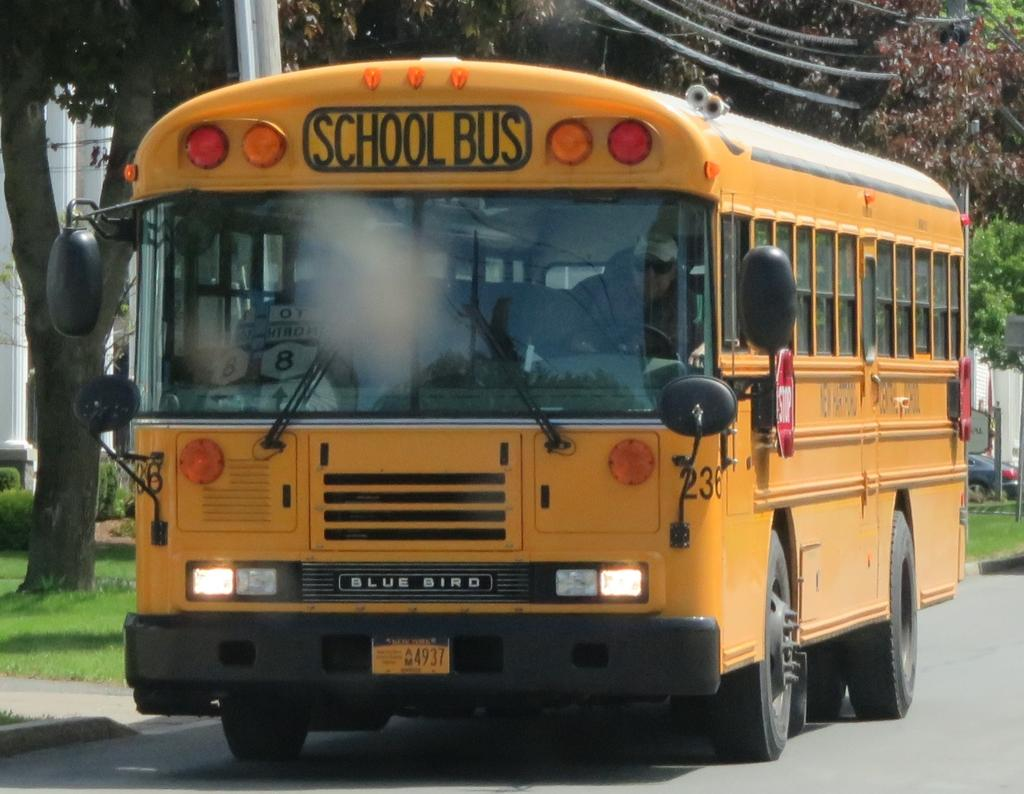What type of vehicle is on the road in the image? There is a school bus on the road in the image. What can be seen in the background of the image? Trees and electrical poles with wires are visible in the background. What type of structure is in the image? There is a building in the image. What type of vegetation is visible in the image? Grass is visible in the image. Can you tell me how many volleyballs are on the roof of the building in the image? There are no volleyballs visible on the roof of the building in the image. Is there a gun visible in the image? There is no gun present in the image. 